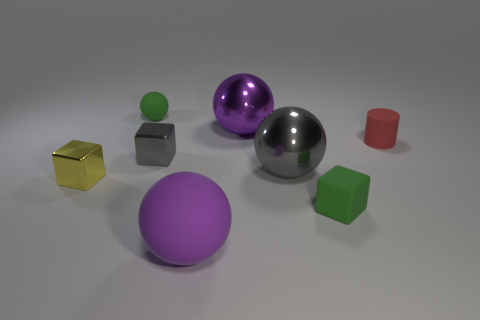Subtract all metal blocks. How many blocks are left? 1 Add 1 cyan things. How many objects exist? 9 Subtract all green blocks. How many blocks are left? 2 Add 3 cubes. How many cubes are left? 6 Add 4 tiny red cylinders. How many tiny red cylinders exist? 5 Subtract 0 purple cylinders. How many objects are left? 8 Subtract all cylinders. How many objects are left? 7 Subtract 1 balls. How many balls are left? 3 Subtract all yellow blocks. Subtract all green cylinders. How many blocks are left? 2 Subtract all blue cylinders. How many brown spheres are left? 0 